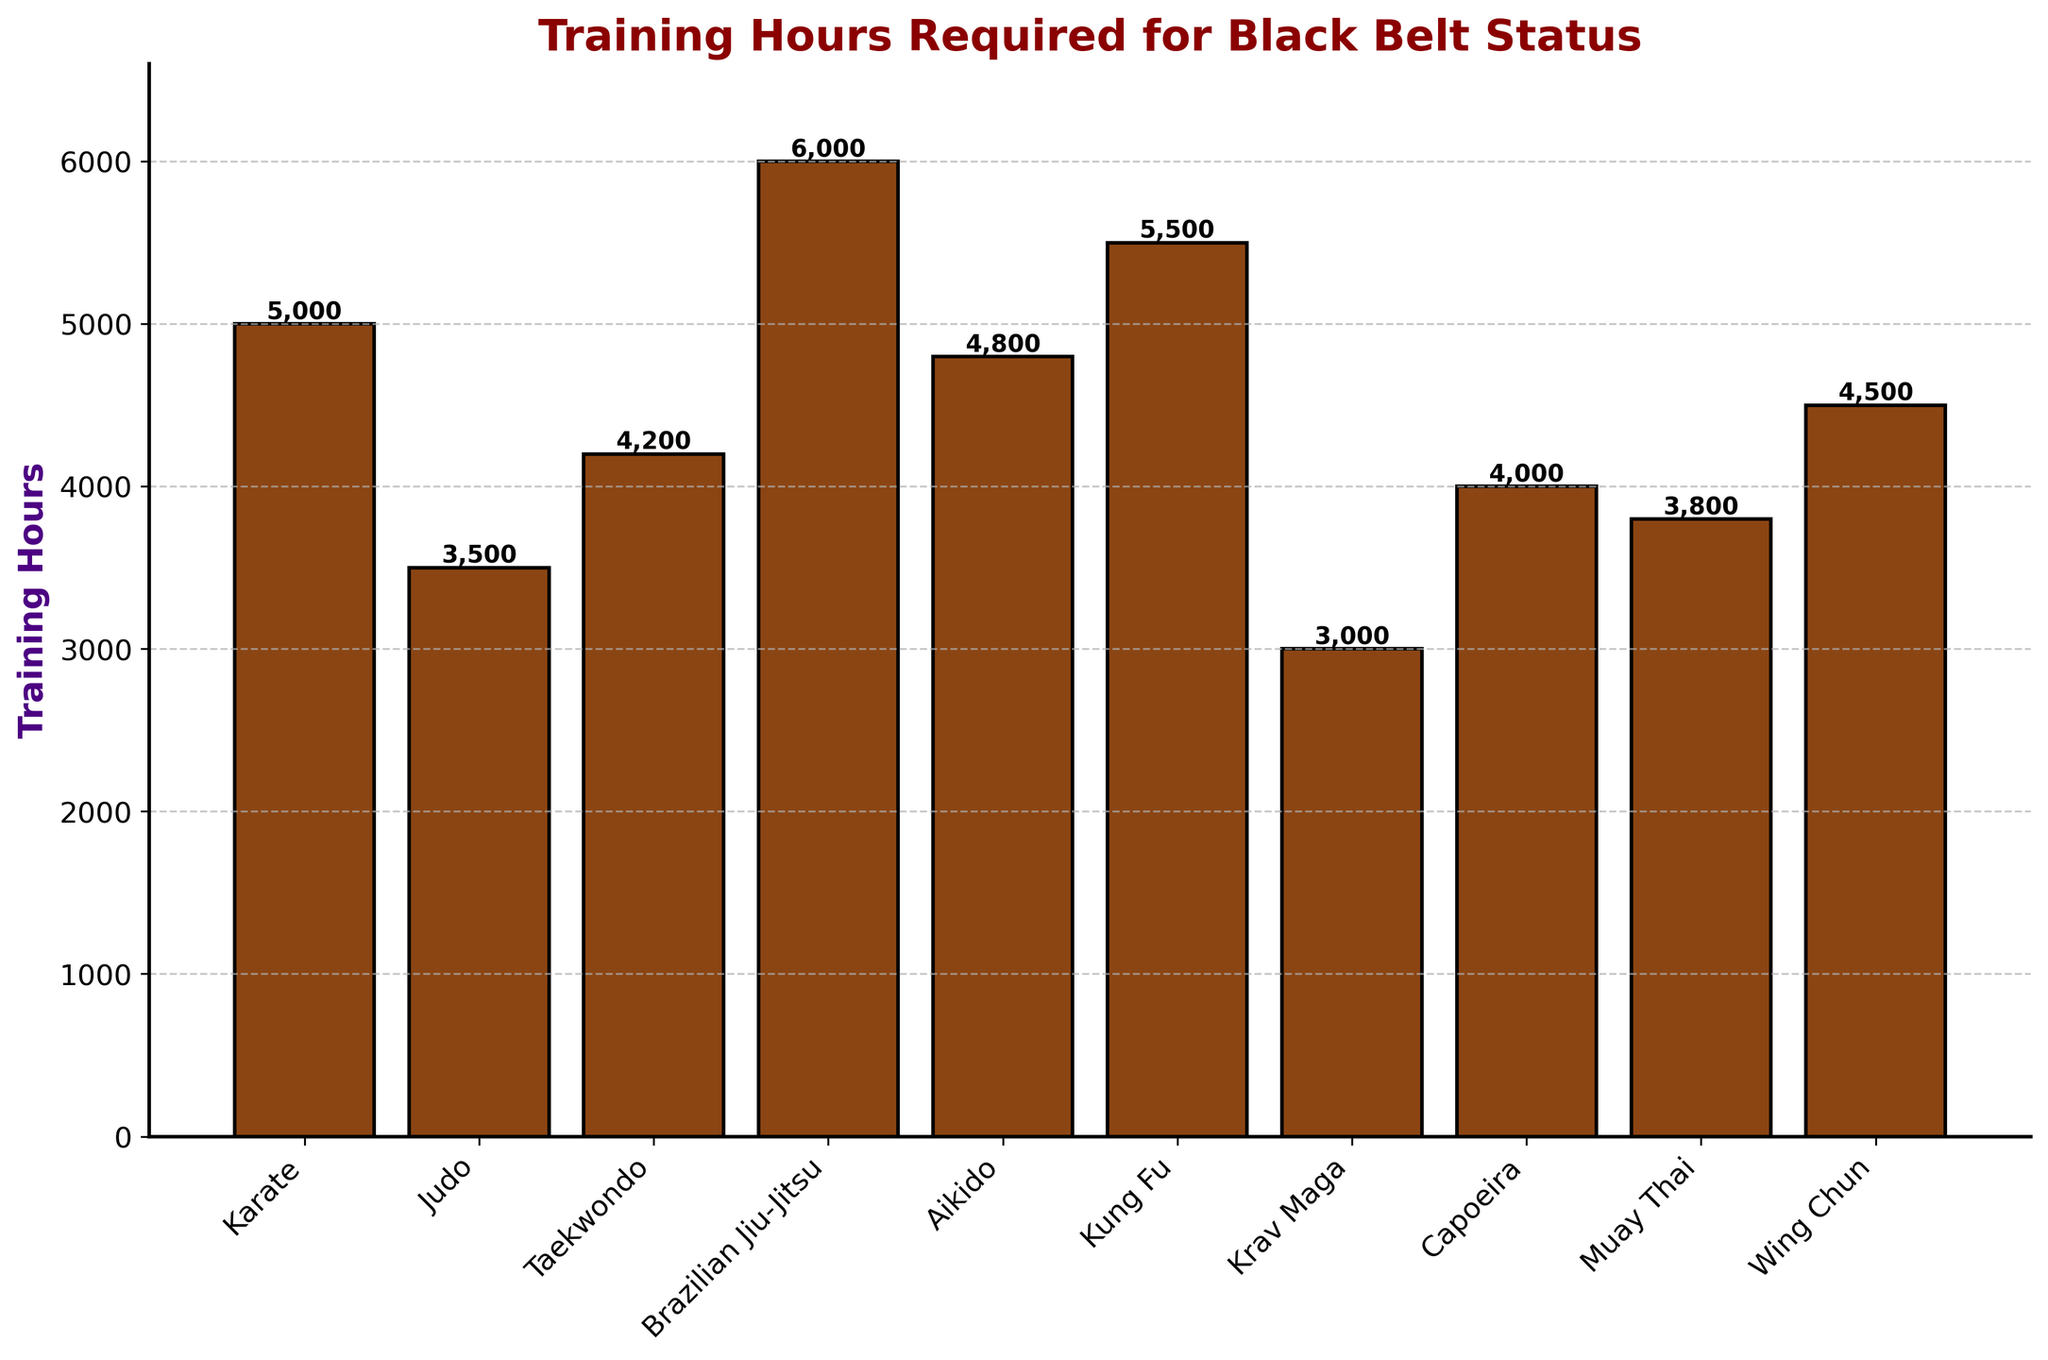Which martial art style requires the most training hours to achieve black belt status? Look at the bar with the greatest height to identify the style that requires the most hours. Brazilian Jiu-Jitsu's bar is the tallest, with 6000 training hours.
Answer: Brazilian Jiu-Jitsu Between Karate and Muay Thai, which one requires fewer training hours? Compare the heights of the bars for Karate and Muay Thai. The bar for Muay Thai is shorter than the bar for Karate, signifying fewer training hours.
Answer: Muay Thai What is the difference in training hours required between Aikido and Capoeira? Find the height of the bars for Aikido (4800 hours) and Capoeira (4000 hours). Calculate the difference: 4800 - 4000 = 800.
Answer: 800 How many martial arts styles require more than 4500 training hours? Count the number of bars with heights exceeding 4500 hours. The bars for Karate, Brazilian Jiu-Jitsu, Kung Fu, and Aikido exceed this threshold, totaling 4 styles.
Answer: 4 Which style requires the least training hours? Identify the shortest bar, which corresponds to the fewest training hours. Krav Maga has the shortest bar with 3000 hours.
Answer: Krav Maga What is the average number of training hours required for all martial arts styles? Sum all the training hours (5000 + 3500 + 4200 + 6000 + 4800 + 5500 + 3000 + 4000 + 3800 + 4500 = 44300) and divide by the number of styles (10). The average is 44300 / 10 = 4430.
Answer: 4430 Which martial arts require fewer training hours than the average? The average is 4430 hours. Identify styles below this average: Judo (3500), Krav Maga (3000), Capoeira (4000), Muay Thai (3800).
Answer: Judo, Krav Maga, Capoeira, Muay Thai What is the total number of training hours for Taekwondo and Wing Chun combined? Find the hours for both styles and add them: Taekwondo (4200) + Wing Chun (4500) = 8700.
Answer: 8700 Which martial art style has a bar color different from the others? Identify bars with a distinctive visual trait. All bars have the same color (#8B4513 brown).
Answer: None 